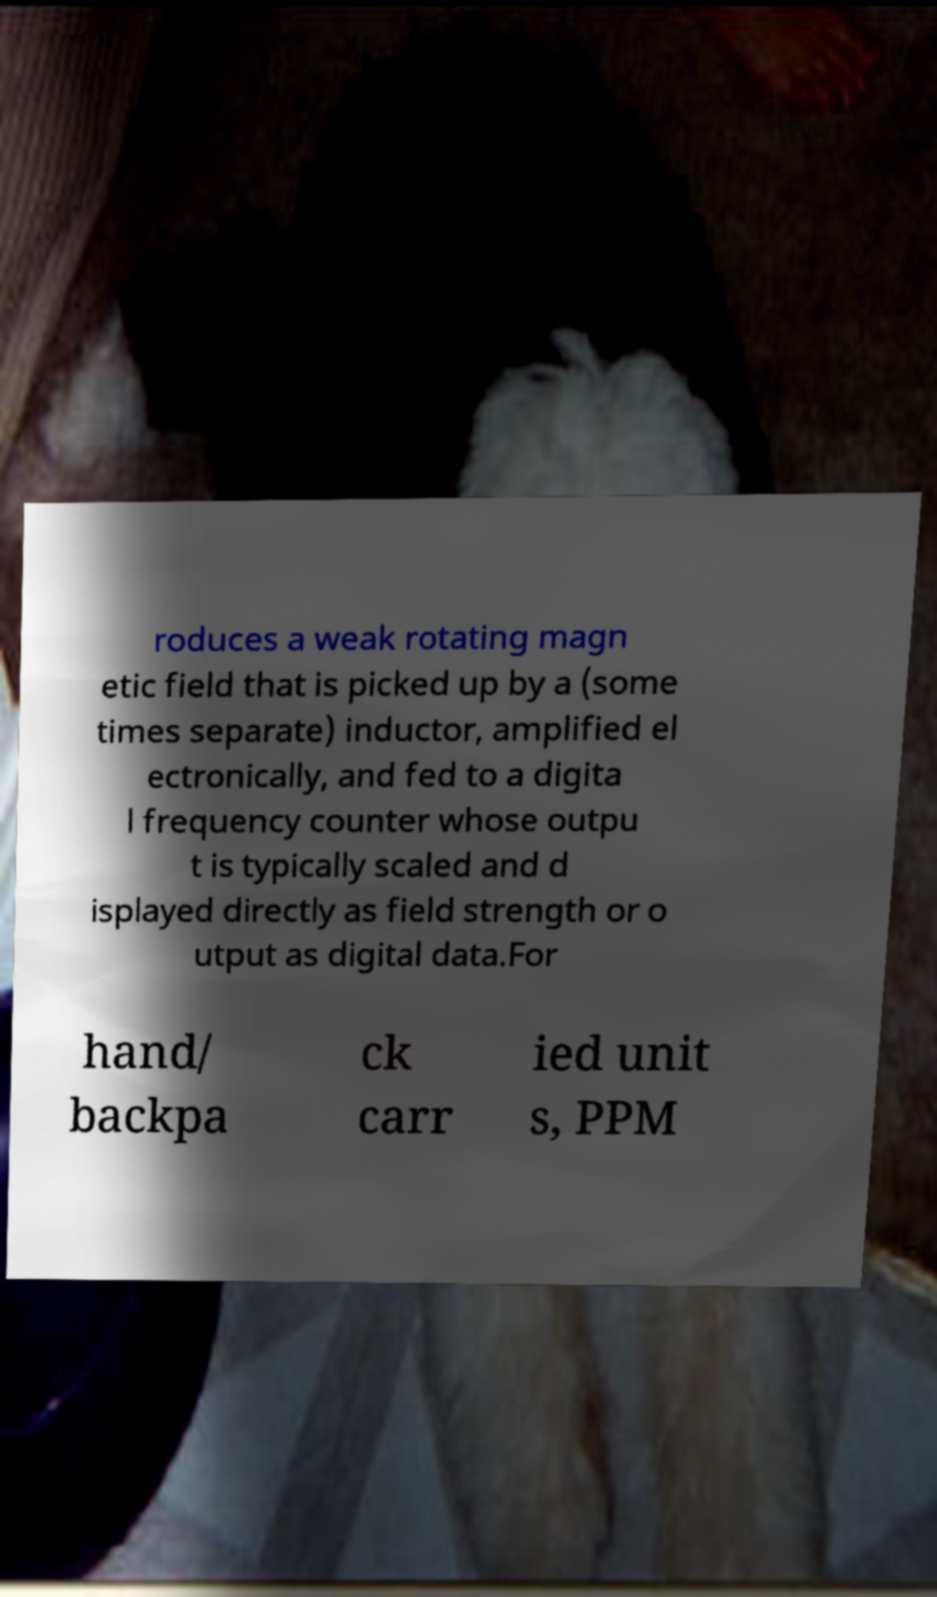Please identify and transcribe the text found in this image. roduces a weak rotating magn etic field that is picked up by a (some times separate) inductor, amplified el ectronically, and fed to a digita l frequency counter whose outpu t is typically scaled and d isplayed directly as field strength or o utput as digital data.For hand/ backpa ck carr ied unit s, PPM 